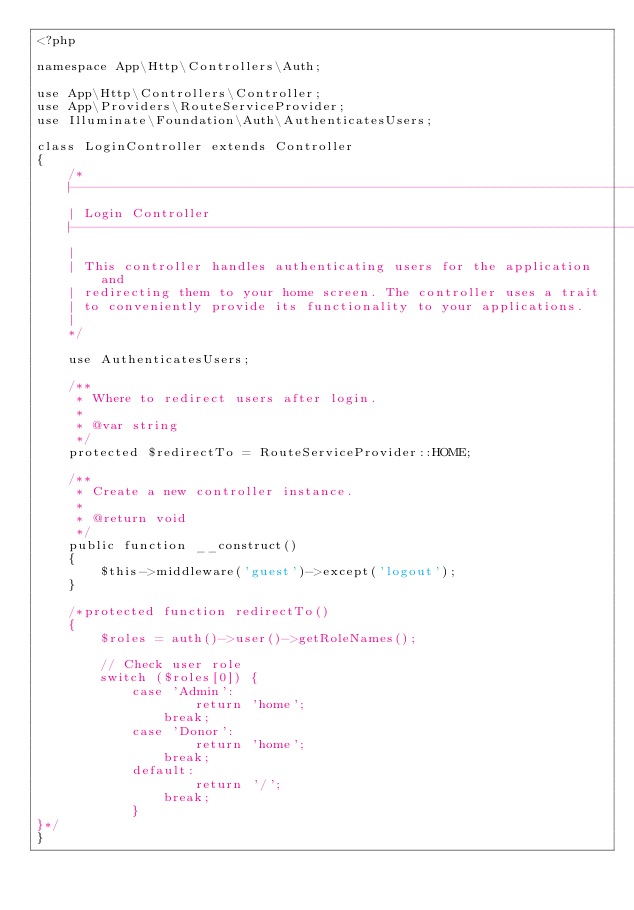Convert code to text. <code><loc_0><loc_0><loc_500><loc_500><_PHP_><?php

namespace App\Http\Controllers\Auth;

use App\Http\Controllers\Controller;
use App\Providers\RouteServiceProvider;
use Illuminate\Foundation\Auth\AuthenticatesUsers;

class LoginController extends Controller
{
    /*
    |--------------------------------------------------------------------------
    | Login Controller
    |--------------------------------------------------------------------------
    |
    | This controller handles authenticating users for the application and
    | redirecting them to your home screen. The controller uses a trait
    | to conveniently provide its functionality to your applications.
    |
    */

    use AuthenticatesUsers;

    /**
     * Where to redirect users after login.
     *
     * @var string
     */
    protected $redirectTo = RouteServiceProvider::HOME;

    /**
     * Create a new controller instance.
     *
     * @return void
     */
    public function __construct()
    {
        $this->middleware('guest')->except('logout');
    }

    /*protected function redirectTo()
    {
        $roles = auth()->user()->getRoleNames();

        // Check user role
        switch ($roles[0]) {
            case 'Admin':
                    return 'home';
                break;
            case 'Donor':
                    return 'home';
                break; 
            default:
                    return '/';  
                break;
            }
}*/
}</code> 